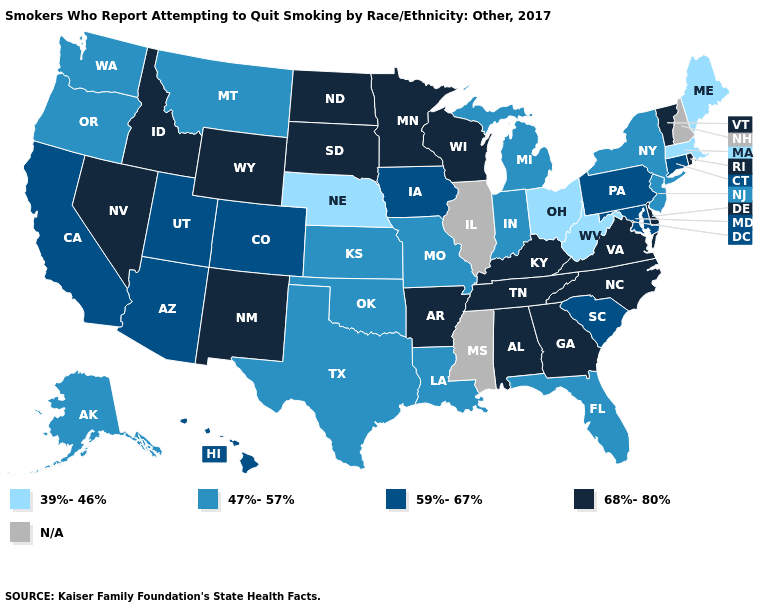Name the states that have a value in the range 68%-80%?
Answer briefly. Alabama, Arkansas, Delaware, Georgia, Idaho, Kentucky, Minnesota, Nevada, New Mexico, North Carolina, North Dakota, Rhode Island, South Dakota, Tennessee, Vermont, Virginia, Wisconsin, Wyoming. What is the value of South Dakota?
Answer briefly. 68%-80%. What is the lowest value in the Northeast?
Be succinct. 39%-46%. How many symbols are there in the legend?
Be succinct. 5. Among the states that border Texas , does New Mexico have the lowest value?
Be succinct. No. Which states have the highest value in the USA?
Write a very short answer. Alabama, Arkansas, Delaware, Georgia, Idaho, Kentucky, Minnesota, Nevada, New Mexico, North Carolina, North Dakota, Rhode Island, South Dakota, Tennessee, Vermont, Virginia, Wisconsin, Wyoming. What is the value of Nevada?
Keep it brief. 68%-80%. What is the highest value in states that border North Dakota?
Be succinct. 68%-80%. What is the lowest value in states that border Kentucky?
Keep it brief. 39%-46%. What is the value of Alabama?
Write a very short answer. 68%-80%. Name the states that have a value in the range 47%-57%?
Quick response, please. Alaska, Florida, Indiana, Kansas, Louisiana, Michigan, Missouri, Montana, New Jersey, New York, Oklahoma, Oregon, Texas, Washington. What is the value of Alaska?
Keep it brief. 47%-57%. Is the legend a continuous bar?
Give a very brief answer. No. Does the first symbol in the legend represent the smallest category?
Write a very short answer. Yes. 